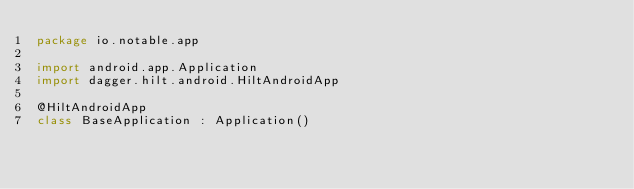Convert code to text. <code><loc_0><loc_0><loc_500><loc_500><_Kotlin_>package io.notable.app

import android.app.Application
import dagger.hilt.android.HiltAndroidApp

@HiltAndroidApp
class BaseApplication : Application()</code> 